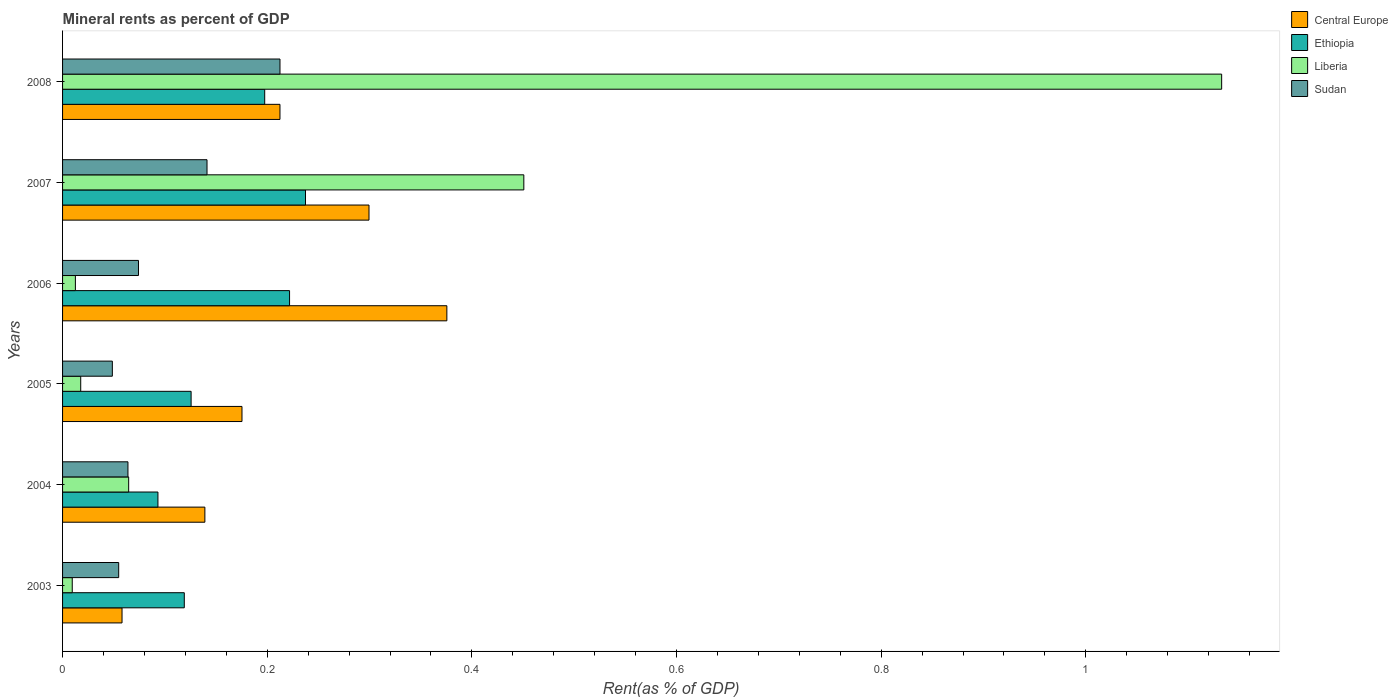How many different coloured bars are there?
Offer a very short reply. 4. How many groups of bars are there?
Provide a succinct answer. 6. Are the number of bars on each tick of the Y-axis equal?
Provide a short and direct response. Yes. How many bars are there on the 1st tick from the top?
Provide a short and direct response. 4. In how many cases, is the number of bars for a given year not equal to the number of legend labels?
Provide a succinct answer. 0. What is the mineral rent in Ethiopia in 2004?
Offer a terse response. 0.09. Across all years, what is the maximum mineral rent in Liberia?
Offer a very short reply. 1.13. Across all years, what is the minimum mineral rent in Central Europe?
Your answer should be very brief. 0.06. In which year was the mineral rent in Central Europe maximum?
Offer a terse response. 2006. In which year was the mineral rent in Central Europe minimum?
Ensure brevity in your answer.  2003. What is the total mineral rent in Sudan in the graph?
Make the answer very short. 0.6. What is the difference between the mineral rent in Sudan in 2003 and that in 2007?
Give a very brief answer. -0.09. What is the difference between the mineral rent in Liberia in 2008 and the mineral rent in Central Europe in 2003?
Offer a terse response. 1.07. What is the average mineral rent in Liberia per year?
Provide a short and direct response. 0.28. In the year 2006, what is the difference between the mineral rent in Sudan and mineral rent in Ethiopia?
Your response must be concise. -0.15. What is the ratio of the mineral rent in Liberia in 2007 to that in 2008?
Offer a terse response. 0.4. Is the difference between the mineral rent in Sudan in 2004 and 2006 greater than the difference between the mineral rent in Ethiopia in 2004 and 2006?
Your answer should be compact. Yes. What is the difference between the highest and the second highest mineral rent in Central Europe?
Your response must be concise. 0.08. What is the difference between the highest and the lowest mineral rent in Central Europe?
Your answer should be compact. 0.32. In how many years, is the mineral rent in Liberia greater than the average mineral rent in Liberia taken over all years?
Give a very brief answer. 2. What does the 4th bar from the top in 2005 represents?
Your answer should be very brief. Central Europe. What does the 4th bar from the bottom in 2005 represents?
Offer a very short reply. Sudan. Is it the case that in every year, the sum of the mineral rent in Sudan and mineral rent in Liberia is greater than the mineral rent in Central Europe?
Provide a short and direct response. No. How many bars are there?
Make the answer very short. 24. Are all the bars in the graph horizontal?
Provide a short and direct response. Yes. How many years are there in the graph?
Ensure brevity in your answer.  6. What is the difference between two consecutive major ticks on the X-axis?
Provide a succinct answer. 0.2. Are the values on the major ticks of X-axis written in scientific E-notation?
Your answer should be compact. No. Where does the legend appear in the graph?
Give a very brief answer. Top right. How many legend labels are there?
Your answer should be compact. 4. How are the legend labels stacked?
Provide a succinct answer. Vertical. What is the title of the graph?
Offer a very short reply. Mineral rents as percent of GDP. What is the label or title of the X-axis?
Provide a short and direct response. Rent(as % of GDP). What is the label or title of the Y-axis?
Provide a succinct answer. Years. What is the Rent(as % of GDP) in Central Europe in 2003?
Offer a very short reply. 0.06. What is the Rent(as % of GDP) of Ethiopia in 2003?
Keep it short and to the point. 0.12. What is the Rent(as % of GDP) in Liberia in 2003?
Make the answer very short. 0.01. What is the Rent(as % of GDP) in Sudan in 2003?
Make the answer very short. 0.05. What is the Rent(as % of GDP) of Central Europe in 2004?
Your response must be concise. 0.14. What is the Rent(as % of GDP) of Ethiopia in 2004?
Your response must be concise. 0.09. What is the Rent(as % of GDP) in Liberia in 2004?
Provide a short and direct response. 0.06. What is the Rent(as % of GDP) of Sudan in 2004?
Offer a very short reply. 0.06. What is the Rent(as % of GDP) in Central Europe in 2005?
Your answer should be very brief. 0.18. What is the Rent(as % of GDP) of Ethiopia in 2005?
Make the answer very short. 0.13. What is the Rent(as % of GDP) in Liberia in 2005?
Provide a short and direct response. 0.02. What is the Rent(as % of GDP) in Sudan in 2005?
Ensure brevity in your answer.  0.05. What is the Rent(as % of GDP) in Central Europe in 2006?
Your answer should be very brief. 0.38. What is the Rent(as % of GDP) of Ethiopia in 2006?
Ensure brevity in your answer.  0.22. What is the Rent(as % of GDP) of Liberia in 2006?
Offer a terse response. 0.01. What is the Rent(as % of GDP) of Sudan in 2006?
Give a very brief answer. 0.07. What is the Rent(as % of GDP) of Central Europe in 2007?
Give a very brief answer. 0.3. What is the Rent(as % of GDP) in Ethiopia in 2007?
Ensure brevity in your answer.  0.24. What is the Rent(as % of GDP) of Liberia in 2007?
Provide a succinct answer. 0.45. What is the Rent(as % of GDP) of Sudan in 2007?
Provide a short and direct response. 0.14. What is the Rent(as % of GDP) in Central Europe in 2008?
Your answer should be compact. 0.21. What is the Rent(as % of GDP) in Ethiopia in 2008?
Your answer should be very brief. 0.2. What is the Rent(as % of GDP) in Liberia in 2008?
Keep it short and to the point. 1.13. What is the Rent(as % of GDP) in Sudan in 2008?
Keep it short and to the point. 0.21. Across all years, what is the maximum Rent(as % of GDP) in Central Europe?
Your answer should be compact. 0.38. Across all years, what is the maximum Rent(as % of GDP) in Ethiopia?
Ensure brevity in your answer.  0.24. Across all years, what is the maximum Rent(as % of GDP) in Liberia?
Keep it short and to the point. 1.13. Across all years, what is the maximum Rent(as % of GDP) of Sudan?
Offer a very short reply. 0.21. Across all years, what is the minimum Rent(as % of GDP) in Central Europe?
Your response must be concise. 0.06. Across all years, what is the minimum Rent(as % of GDP) of Ethiopia?
Offer a very short reply. 0.09. Across all years, what is the minimum Rent(as % of GDP) in Liberia?
Your response must be concise. 0.01. Across all years, what is the minimum Rent(as % of GDP) of Sudan?
Provide a short and direct response. 0.05. What is the total Rent(as % of GDP) in Central Europe in the graph?
Provide a short and direct response. 1.26. What is the total Rent(as % of GDP) in Ethiopia in the graph?
Keep it short and to the point. 0.99. What is the total Rent(as % of GDP) of Liberia in the graph?
Keep it short and to the point. 1.69. What is the total Rent(as % of GDP) of Sudan in the graph?
Your answer should be compact. 0.6. What is the difference between the Rent(as % of GDP) in Central Europe in 2003 and that in 2004?
Provide a short and direct response. -0.08. What is the difference between the Rent(as % of GDP) in Ethiopia in 2003 and that in 2004?
Offer a very short reply. 0.03. What is the difference between the Rent(as % of GDP) in Liberia in 2003 and that in 2004?
Provide a short and direct response. -0.06. What is the difference between the Rent(as % of GDP) of Sudan in 2003 and that in 2004?
Provide a short and direct response. -0.01. What is the difference between the Rent(as % of GDP) of Central Europe in 2003 and that in 2005?
Make the answer very short. -0.12. What is the difference between the Rent(as % of GDP) in Ethiopia in 2003 and that in 2005?
Give a very brief answer. -0.01. What is the difference between the Rent(as % of GDP) in Liberia in 2003 and that in 2005?
Provide a short and direct response. -0.01. What is the difference between the Rent(as % of GDP) of Sudan in 2003 and that in 2005?
Give a very brief answer. 0.01. What is the difference between the Rent(as % of GDP) in Central Europe in 2003 and that in 2006?
Provide a short and direct response. -0.32. What is the difference between the Rent(as % of GDP) of Ethiopia in 2003 and that in 2006?
Give a very brief answer. -0.1. What is the difference between the Rent(as % of GDP) in Liberia in 2003 and that in 2006?
Ensure brevity in your answer.  -0. What is the difference between the Rent(as % of GDP) of Sudan in 2003 and that in 2006?
Provide a short and direct response. -0.02. What is the difference between the Rent(as % of GDP) of Central Europe in 2003 and that in 2007?
Your answer should be compact. -0.24. What is the difference between the Rent(as % of GDP) of Ethiopia in 2003 and that in 2007?
Keep it short and to the point. -0.12. What is the difference between the Rent(as % of GDP) in Liberia in 2003 and that in 2007?
Your response must be concise. -0.44. What is the difference between the Rent(as % of GDP) of Sudan in 2003 and that in 2007?
Offer a very short reply. -0.09. What is the difference between the Rent(as % of GDP) in Central Europe in 2003 and that in 2008?
Make the answer very short. -0.15. What is the difference between the Rent(as % of GDP) in Ethiopia in 2003 and that in 2008?
Provide a short and direct response. -0.08. What is the difference between the Rent(as % of GDP) in Liberia in 2003 and that in 2008?
Provide a short and direct response. -1.12. What is the difference between the Rent(as % of GDP) of Sudan in 2003 and that in 2008?
Keep it short and to the point. -0.16. What is the difference between the Rent(as % of GDP) of Central Europe in 2004 and that in 2005?
Ensure brevity in your answer.  -0.04. What is the difference between the Rent(as % of GDP) in Ethiopia in 2004 and that in 2005?
Offer a very short reply. -0.03. What is the difference between the Rent(as % of GDP) of Liberia in 2004 and that in 2005?
Provide a succinct answer. 0.05. What is the difference between the Rent(as % of GDP) in Sudan in 2004 and that in 2005?
Offer a terse response. 0.02. What is the difference between the Rent(as % of GDP) in Central Europe in 2004 and that in 2006?
Your response must be concise. -0.24. What is the difference between the Rent(as % of GDP) in Ethiopia in 2004 and that in 2006?
Provide a succinct answer. -0.13. What is the difference between the Rent(as % of GDP) of Liberia in 2004 and that in 2006?
Provide a short and direct response. 0.05. What is the difference between the Rent(as % of GDP) of Sudan in 2004 and that in 2006?
Your answer should be very brief. -0.01. What is the difference between the Rent(as % of GDP) in Central Europe in 2004 and that in 2007?
Provide a short and direct response. -0.16. What is the difference between the Rent(as % of GDP) in Ethiopia in 2004 and that in 2007?
Your response must be concise. -0.14. What is the difference between the Rent(as % of GDP) in Liberia in 2004 and that in 2007?
Offer a very short reply. -0.39. What is the difference between the Rent(as % of GDP) of Sudan in 2004 and that in 2007?
Offer a terse response. -0.08. What is the difference between the Rent(as % of GDP) in Central Europe in 2004 and that in 2008?
Your answer should be compact. -0.07. What is the difference between the Rent(as % of GDP) of Ethiopia in 2004 and that in 2008?
Provide a succinct answer. -0.1. What is the difference between the Rent(as % of GDP) in Liberia in 2004 and that in 2008?
Provide a succinct answer. -1.07. What is the difference between the Rent(as % of GDP) of Sudan in 2004 and that in 2008?
Keep it short and to the point. -0.15. What is the difference between the Rent(as % of GDP) in Central Europe in 2005 and that in 2006?
Keep it short and to the point. -0.2. What is the difference between the Rent(as % of GDP) of Ethiopia in 2005 and that in 2006?
Keep it short and to the point. -0.1. What is the difference between the Rent(as % of GDP) of Liberia in 2005 and that in 2006?
Offer a very short reply. 0.01. What is the difference between the Rent(as % of GDP) of Sudan in 2005 and that in 2006?
Your answer should be compact. -0.03. What is the difference between the Rent(as % of GDP) in Central Europe in 2005 and that in 2007?
Your answer should be compact. -0.12. What is the difference between the Rent(as % of GDP) of Ethiopia in 2005 and that in 2007?
Keep it short and to the point. -0.11. What is the difference between the Rent(as % of GDP) of Liberia in 2005 and that in 2007?
Offer a very short reply. -0.43. What is the difference between the Rent(as % of GDP) in Sudan in 2005 and that in 2007?
Keep it short and to the point. -0.09. What is the difference between the Rent(as % of GDP) of Central Europe in 2005 and that in 2008?
Your response must be concise. -0.04. What is the difference between the Rent(as % of GDP) in Ethiopia in 2005 and that in 2008?
Provide a short and direct response. -0.07. What is the difference between the Rent(as % of GDP) of Liberia in 2005 and that in 2008?
Provide a succinct answer. -1.11. What is the difference between the Rent(as % of GDP) in Sudan in 2005 and that in 2008?
Provide a short and direct response. -0.16. What is the difference between the Rent(as % of GDP) of Central Europe in 2006 and that in 2007?
Keep it short and to the point. 0.08. What is the difference between the Rent(as % of GDP) of Ethiopia in 2006 and that in 2007?
Keep it short and to the point. -0.02. What is the difference between the Rent(as % of GDP) in Liberia in 2006 and that in 2007?
Offer a terse response. -0.44. What is the difference between the Rent(as % of GDP) in Sudan in 2006 and that in 2007?
Your answer should be compact. -0.07. What is the difference between the Rent(as % of GDP) of Central Europe in 2006 and that in 2008?
Keep it short and to the point. 0.16. What is the difference between the Rent(as % of GDP) in Ethiopia in 2006 and that in 2008?
Give a very brief answer. 0.02. What is the difference between the Rent(as % of GDP) in Liberia in 2006 and that in 2008?
Offer a very short reply. -1.12. What is the difference between the Rent(as % of GDP) in Sudan in 2006 and that in 2008?
Provide a short and direct response. -0.14. What is the difference between the Rent(as % of GDP) of Central Europe in 2007 and that in 2008?
Give a very brief answer. 0.09. What is the difference between the Rent(as % of GDP) of Ethiopia in 2007 and that in 2008?
Keep it short and to the point. 0.04. What is the difference between the Rent(as % of GDP) of Liberia in 2007 and that in 2008?
Your answer should be compact. -0.68. What is the difference between the Rent(as % of GDP) of Sudan in 2007 and that in 2008?
Offer a terse response. -0.07. What is the difference between the Rent(as % of GDP) in Central Europe in 2003 and the Rent(as % of GDP) in Ethiopia in 2004?
Provide a succinct answer. -0.04. What is the difference between the Rent(as % of GDP) of Central Europe in 2003 and the Rent(as % of GDP) of Liberia in 2004?
Keep it short and to the point. -0.01. What is the difference between the Rent(as % of GDP) in Central Europe in 2003 and the Rent(as % of GDP) in Sudan in 2004?
Provide a short and direct response. -0.01. What is the difference between the Rent(as % of GDP) in Ethiopia in 2003 and the Rent(as % of GDP) in Liberia in 2004?
Your answer should be very brief. 0.05. What is the difference between the Rent(as % of GDP) in Ethiopia in 2003 and the Rent(as % of GDP) in Sudan in 2004?
Ensure brevity in your answer.  0.06. What is the difference between the Rent(as % of GDP) of Liberia in 2003 and the Rent(as % of GDP) of Sudan in 2004?
Make the answer very short. -0.05. What is the difference between the Rent(as % of GDP) in Central Europe in 2003 and the Rent(as % of GDP) in Ethiopia in 2005?
Offer a very short reply. -0.07. What is the difference between the Rent(as % of GDP) in Central Europe in 2003 and the Rent(as % of GDP) in Liberia in 2005?
Provide a short and direct response. 0.04. What is the difference between the Rent(as % of GDP) of Central Europe in 2003 and the Rent(as % of GDP) of Sudan in 2005?
Your answer should be very brief. 0.01. What is the difference between the Rent(as % of GDP) in Ethiopia in 2003 and the Rent(as % of GDP) in Liberia in 2005?
Your answer should be compact. 0.1. What is the difference between the Rent(as % of GDP) of Ethiopia in 2003 and the Rent(as % of GDP) of Sudan in 2005?
Keep it short and to the point. 0.07. What is the difference between the Rent(as % of GDP) in Liberia in 2003 and the Rent(as % of GDP) in Sudan in 2005?
Provide a succinct answer. -0.04. What is the difference between the Rent(as % of GDP) of Central Europe in 2003 and the Rent(as % of GDP) of Ethiopia in 2006?
Offer a very short reply. -0.16. What is the difference between the Rent(as % of GDP) in Central Europe in 2003 and the Rent(as % of GDP) in Liberia in 2006?
Ensure brevity in your answer.  0.05. What is the difference between the Rent(as % of GDP) in Central Europe in 2003 and the Rent(as % of GDP) in Sudan in 2006?
Your response must be concise. -0.02. What is the difference between the Rent(as % of GDP) of Ethiopia in 2003 and the Rent(as % of GDP) of Liberia in 2006?
Keep it short and to the point. 0.11. What is the difference between the Rent(as % of GDP) of Ethiopia in 2003 and the Rent(as % of GDP) of Sudan in 2006?
Offer a terse response. 0.04. What is the difference between the Rent(as % of GDP) of Liberia in 2003 and the Rent(as % of GDP) of Sudan in 2006?
Give a very brief answer. -0.06. What is the difference between the Rent(as % of GDP) of Central Europe in 2003 and the Rent(as % of GDP) of Ethiopia in 2007?
Offer a very short reply. -0.18. What is the difference between the Rent(as % of GDP) in Central Europe in 2003 and the Rent(as % of GDP) in Liberia in 2007?
Your response must be concise. -0.39. What is the difference between the Rent(as % of GDP) in Central Europe in 2003 and the Rent(as % of GDP) in Sudan in 2007?
Your response must be concise. -0.08. What is the difference between the Rent(as % of GDP) in Ethiopia in 2003 and the Rent(as % of GDP) in Liberia in 2007?
Provide a succinct answer. -0.33. What is the difference between the Rent(as % of GDP) of Ethiopia in 2003 and the Rent(as % of GDP) of Sudan in 2007?
Keep it short and to the point. -0.02. What is the difference between the Rent(as % of GDP) of Liberia in 2003 and the Rent(as % of GDP) of Sudan in 2007?
Keep it short and to the point. -0.13. What is the difference between the Rent(as % of GDP) in Central Europe in 2003 and the Rent(as % of GDP) in Ethiopia in 2008?
Provide a short and direct response. -0.14. What is the difference between the Rent(as % of GDP) in Central Europe in 2003 and the Rent(as % of GDP) in Liberia in 2008?
Give a very brief answer. -1.07. What is the difference between the Rent(as % of GDP) of Central Europe in 2003 and the Rent(as % of GDP) of Sudan in 2008?
Give a very brief answer. -0.15. What is the difference between the Rent(as % of GDP) in Ethiopia in 2003 and the Rent(as % of GDP) in Liberia in 2008?
Your answer should be compact. -1.01. What is the difference between the Rent(as % of GDP) in Ethiopia in 2003 and the Rent(as % of GDP) in Sudan in 2008?
Keep it short and to the point. -0.09. What is the difference between the Rent(as % of GDP) of Liberia in 2003 and the Rent(as % of GDP) of Sudan in 2008?
Your answer should be compact. -0.2. What is the difference between the Rent(as % of GDP) in Central Europe in 2004 and the Rent(as % of GDP) in Ethiopia in 2005?
Keep it short and to the point. 0.01. What is the difference between the Rent(as % of GDP) of Central Europe in 2004 and the Rent(as % of GDP) of Liberia in 2005?
Offer a terse response. 0.12. What is the difference between the Rent(as % of GDP) of Central Europe in 2004 and the Rent(as % of GDP) of Sudan in 2005?
Your response must be concise. 0.09. What is the difference between the Rent(as % of GDP) in Ethiopia in 2004 and the Rent(as % of GDP) in Liberia in 2005?
Make the answer very short. 0.08. What is the difference between the Rent(as % of GDP) in Ethiopia in 2004 and the Rent(as % of GDP) in Sudan in 2005?
Make the answer very short. 0.04. What is the difference between the Rent(as % of GDP) in Liberia in 2004 and the Rent(as % of GDP) in Sudan in 2005?
Your answer should be compact. 0.02. What is the difference between the Rent(as % of GDP) in Central Europe in 2004 and the Rent(as % of GDP) in Ethiopia in 2006?
Provide a succinct answer. -0.08. What is the difference between the Rent(as % of GDP) of Central Europe in 2004 and the Rent(as % of GDP) of Liberia in 2006?
Provide a short and direct response. 0.13. What is the difference between the Rent(as % of GDP) of Central Europe in 2004 and the Rent(as % of GDP) of Sudan in 2006?
Make the answer very short. 0.06. What is the difference between the Rent(as % of GDP) of Ethiopia in 2004 and the Rent(as % of GDP) of Liberia in 2006?
Provide a short and direct response. 0.08. What is the difference between the Rent(as % of GDP) in Ethiopia in 2004 and the Rent(as % of GDP) in Sudan in 2006?
Your answer should be very brief. 0.02. What is the difference between the Rent(as % of GDP) of Liberia in 2004 and the Rent(as % of GDP) of Sudan in 2006?
Provide a succinct answer. -0.01. What is the difference between the Rent(as % of GDP) in Central Europe in 2004 and the Rent(as % of GDP) in Ethiopia in 2007?
Ensure brevity in your answer.  -0.1. What is the difference between the Rent(as % of GDP) of Central Europe in 2004 and the Rent(as % of GDP) of Liberia in 2007?
Ensure brevity in your answer.  -0.31. What is the difference between the Rent(as % of GDP) in Central Europe in 2004 and the Rent(as % of GDP) in Sudan in 2007?
Your answer should be very brief. -0. What is the difference between the Rent(as % of GDP) of Ethiopia in 2004 and the Rent(as % of GDP) of Liberia in 2007?
Your answer should be compact. -0.36. What is the difference between the Rent(as % of GDP) in Ethiopia in 2004 and the Rent(as % of GDP) in Sudan in 2007?
Ensure brevity in your answer.  -0.05. What is the difference between the Rent(as % of GDP) of Liberia in 2004 and the Rent(as % of GDP) of Sudan in 2007?
Make the answer very short. -0.08. What is the difference between the Rent(as % of GDP) of Central Europe in 2004 and the Rent(as % of GDP) of Ethiopia in 2008?
Provide a short and direct response. -0.06. What is the difference between the Rent(as % of GDP) in Central Europe in 2004 and the Rent(as % of GDP) in Liberia in 2008?
Your answer should be very brief. -0.99. What is the difference between the Rent(as % of GDP) in Central Europe in 2004 and the Rent(as % of GDP) in Sudan in 2008?
Ensure brevity in your answer.  -0.07. What is the difference between the Rent(as % of GDP) in Ethiopia in 2004 and the Rent(as % of GDP) in Liberia in 2008?
Your answer should be very brief. -1.04. What is the difference between the Rent(as % of GDP) in Ethiopia in 2004 and the Rent(as % of GDP) in Sudan in 2008?
Provide a short and direct response. -0.12. What is the difference between the Rent(as % of GDP) of Liberia in 2004 and the Rent(as % of GDP) of Sudan in 2008?
Your answer should be compact. -0.15. What is the difference between the Rent(as % of GDP) in Central Europe in 2005 and the Rent(as % of GDP) in Ethiopia in 2006?
Offer a terse response. -0.05. What is the difference between the Rent(as % of GDP) of Central Europe in 2005 and the Rent(as % of GDP) of Liberia in 2006?
Your answer should be very brief. 0.16. What is the difference between the Rent(as % of GDP) of Central Europe in 2005 and the Rent(as % of GDP) of Sudan in 2006?
Ensure brevity in your answer.  0.1. What is the difference between the Rent(as % of GDP) in Ethiopia in 2005 and the Rent(as % of GDP) in Liberia in 2006?
Ensure brevity in your answer.  0.11. What is the difference between the Rent(as % of GDP) in Ethiopia in 2005 and the Rent(as % of GDP) in Sudan in 2006?
Offer a very short reply. 0.05. What is the difference between the Rent(as % of GDP) in Liberia in 2005 and the Rent(as % of GDP) in Sudan in 2006?
Make the answer very short. -0.06. What is the difference between the Rent(as % of GDP) in Central Europe in 2005 and the Rent(as % of GDP) in Ethiopia in 2007?
Offer a very short reply. -0.06. What is the difference between the Rent(as % of GDP) in Central Europe in 2005 and the Rent(as % of GDP) in Liberia in 2007?
Keep it short and to the point. -0.28. What is the difference between the Rent(as % of GDP) of Central Europe in 2005 and the Rent(as % of GDP) of Sudan in 2007?
Offer a terse response. 0.03. What is the difference between the Rent(as % of GDP) in Ethiopia in 2005 and the Rent(as % of GDP) in Liberia in 2007?
Provide a short and direct response. -0.33. What is the difference between the Rent(as % of GDP) in Ethiopia in 2005 and the Rent(as % of GDP) in Sudan in 2007?
Your answer should be compact. -0.02. What is the difference between the Rent(as % of GDP) of Liberia in 2005 and the Rent(as % of GDP) of Sudan in 2007?
Your response must be concise. -0.12. What is the difference between the Rent(as % of GDP) of Central Europe in 2005 and the Rent(as % of GDP) of Ethiopia in 2008?
Make the answer very short. -0.02. What is the difference between the Rent(as % of GDP) in Central Europe in 2005 and the Rent(as % of GDP) in Liberia in 2008?
Your answer should be very brief. -0.96. What is the difference between the Rent(as % of GDP) of Central Europe in 2005 and the Rent(as % of GDP) of Sudan in 2008?
Make the answer very short. -0.04. What is the difference between the Rent(as % of GDP) of Ethiopia in 2005 and the Rent(as % of GDP) of Liberia in 2008?
Offer a very short reply. -1.01. What is the difference between the Rent(as % of GDP) in Ethiopia in 2005 and the Rent(as % of GDP) in Sudan in 2008?
Provide a succinct answer. -0.09. What is the difference between the Rent(as % of GDP) in Liberia in 2005 and the Rent(as % of GDP) in Sudan in 2008?
Offer a very short reply. -0.19. What is the difference between the Rent(as % of GDP) in Central Europe in 2006 and the Rent(as % of GDP) in Ethiopia in 2007?
Keep it short and to the point. 0.14. What is the difference between the Rent(as % of GDP) of Central Europe in 2006 and the Rent(as % of GDP) of Liberia in 2007?
Offer a terse response. -0.08. What is the difference between the Rent(as % of GDP) in Central Europe in 2006 and the Rent(as % of GDP) in Sudan in 2007?
Ensure brevity in your answer.  0.23. What is the difference between the Rent(as % of GDP) of Ethiopia in 2006 and the Rent(as % of GDP) of Liberia in 2007?
Ensure brevity in your answer.  -0.23. What is the difference between the Rent(as % of GDP) in Ethiopia in 2006 and the Rent(as % of GDP) in Sudan in 2007?
Provide a short and direct response. 0.08. What is the difference between the Rent(as % of GDP) of Liberia in 2006 and the Rent(as % of GDP) of Sudan in 2007?
Keep it short and to the point. -0.13. What is the difference between the Rent(as % of GDP) of Central Europe in 2006 and the Rent(as % of GDP) of Ethiopia in 2008?
Your answer should be very brief. 0.18. What is the difference between the Rent(as % of GDP) of Central Europe in 2006 and the Rent(as % of GDP) of Liberia in 2008?
Give a very brief answer. -0.76. What is the difference between the Rent(as % of GDP) in Central Europe in 2006 and the Rent(as % of GDP) in Sudan in 2008?
Offer a very short reply. 0.16. What is the difference between the Rent(as % of GDP) of Ethiopia in 2006 and the Rent(as % of GDP) of Liberia in 2008?
Provide a succinct answer. -0.91. What is the difference between the Rent(as % of GDP) of Ethiopia in 2006 and the Rent(as % of GDP) of Sudan in 2008?
Your answer should be very brief. 0.01. What is the difference between the Rent(as % of GDP) in Liberia in 2006 and the Rent(as % of GDP) in Sudan in 2008?
Give a very brief answer. -0.2. What is the difference between the Rent(as % of GDP) in Central Europe in 2007 and the Rent(as % of GDP) in Ethiopia in 2008?
Your answer should be compact. 0.1. What is the difference between the Rent(as % of GDP) of Central Europe in 2007 and the Rent(as % of GDP) of Sudan in 2008?
Offer a very short reply. 0.09. What is the difference between the Rent(as % of GDP) in Ethiopia in 2007 and the Rent(as % of GDP) in Liberia in 2008?
Provide a succinct answer. -0.9. What is the difference between the Rent(as % of GDP) of Ethiopia in 2007 and the Rent(as % of GDP) of Sudan in 2008?
Offer a very short reply. 0.02. What is the difference between the Rent(as % of GDP) in Liberia in 2007 and the Rent(as % of GDP) in Sudan in 2008?
Offer a terse response. 0.24. What is the average Rent(as % of GDP) in Central Europe per year?
Your response must be concise. 0.21. What is the average Rent(as % of GDP) of Ethiopia per year?
Provide a succinct answer. 0.17. What is the average Rent(as % of GDP) of Liberia per year?
Provide a short and direct response. 0.28. What is the average Rent(as % of GDP) of Sudan per year?
Offer a terse response. 0.1. In the year 2003, what is the difference between the Rent(as % of GDP) in Central Europe and Rent(as % of GDP) in Ethiopia?
Your answer should be compact. -0.06. In the year 2003, what is the difference between the Rent(as % of GDP) of Central Europe and Rent(as % of GDP) of Liberia?
Offer a terse response. 0.05. In the year 2003, what is the difference between the Rent(as % of GDP) of Central Europe and Rent(as % of GDP) of Sudan?
Make the answer very short. 0. In the year 2003, what is the difference between the Rent(as % of GDP) of Ethiopia and Rent(as % of GDP) of Liberia?
Make the answer very short. 0.11. In the year 2003, what is the difference between the Rent(as % of GDP) of Ethiopia and Rent(as % of GDP) of Sudan?
Your response must be concise. 0.06. In the year 2003, what is the difference between the Rent(as % of GDP) of Liberia and Rent(as % of GDP) of Sudan?
Keep it short and to the point. -0.05. In the year 2004, what is the difference between the Rent(as % of GDP) in Central Europe and Rent(as % of GDP) in Ethiopia?
Ensure brevity in your answer.  0.05. In the year 2004, what is the difference between the Rent(as % of GDP) of Central Europe and Rent(as % of GDP) of Liberia?
Your response must be concise. 0.07. In the year 2004, what is the difference between the Rent(as % of GDP) in Central Europe and Rent(as % of GDP) in Sudan?
Ensure brevity in your answer.  0.08. In the year 2004, what is the difference between the Rent(as % of GDP) of Ethiopia and Rent(as % of GDP) of Liberia?
Your answer should be compact. 0.03. In the year 2004, what is the difference between the Rent(as % of GDP) in Ethiopia and Rent(as % of GDP) in Sudan?
Offer a very short reply. 0.03. In the year 2004, what is the difference between the Rent(as % of GDP) of Liberia and Rent(as % of GDP) of Sudan?
Give a very brief answer. 0. In the year 2005, what is the difference between the Rent(as % of GDP) in Central Europe and Rent(as % of GDP) in Ethiopia?
Ensure brevity in your answer.  0.05. In the year 2005, what is the difference between the Rent(as % of GDP) in Central Europe and Rent(as % of GDP) in Liberia?
Offer a terse response. 0.16. In the year 2005, what is the difference between the Rent(as % of GDP) of Central Europe and Rent(as % of GDP) of Sudan?
Your response must be concise. 0.13. In the year 2005, what is the difference between the Rent(as % of GDP) of Ethiopia and Rent(as % of GDP) of Liberia?
Provide a short and direct response. 0.11. In the year 2005, what is the difference between the Rent(as % of GDP) in Ethiopia and Rent(as % of GDP) in Sudan?
Ensure brevity in your answer.  0.08. In the year 2005, what is the difference between the Rent(as % of GDP) in Liberia and Rent(as % of GDP) in Sudan?
Ensure brevity in your answer.  -0.03. In the year 2006, what is the difference between the Rent(as % of GDP) in Central Europe and Rent(as % of GDP) in Ethiopia?
Your answer should be very brief. 0.15. In the year 2006, what is the difference between the Rent(as % of GDP) of Central Europe and Rent(as % of GDP) of Liberia?
Provide a succinct answer. 0.36. In the year 2006, what is the difference between the Rent(as % of GDP) in Central Europe and Rent(as % of GDP) in Sudan?
Offer a terse response. 0.3. In the year 2006, what is the difference between the Rent(as % of GDP) in Ethiopia and Rent(as % of GDP) in Liberia?
Make the answer very short. 0.21. In the year 2006, what is the difference between the Rent(as % of GDP) of Ethiopia and Rent(as % of GDP) of Sudan?
Your answer should be compact. 0.15. In the year 2006, what is the difference between the Rent(as % of GDP) of Liberia and Rent(as % of GDP) of Sudan?
Offer a very short reply. -0.06. In the year 2007, what is the difference between the Rent(as % of GDP) of Central Europe and Rent(as % of GDP) of Ethiopia?
Your answer should be compact. 0.06. In the year 2007, what is the difference between the Rent(as % of GDP) of Central Europe and Rent(as % of GDP) of Liberia?
Offer a very short reply. -0.15. In the year 2007, what is the difference between the Rent(as % of GDP) in Central Europe and Rent(as % of GDP) in Sudan?
Provide a succinct answer. 0.16. In the year 2007, what is the difference between the Rent(as % of GDP) in Ethiopia and Rent(as % of GDP) in Liberia?
Keep it short and to the point. -0.21. In the year 2007, what is the difference between the Rent(as % of GDP) of Ethiopia and Rent(as % of GDP) of Sudan?
Ensure brevity in your answer.  0.1. In the year 2007, what is the difference between the Rent(as % of GDP) in Liberia and Rent(as % of GDP) in Sudan?
Ensure brevity in your answer.  0.31. In the year 2008, what is the difference between the Rent(as % of GDP) in Central Europe and Rent(as % of GDP) in Ethiopia?
Keep it short and to the point. 0.01. In the year 2008, what is the difference between the Rent(as % of GDP) of Central Europe and Rent(as % of GDP) of Liberia?
Provide a succinct answer. -0.92. In the year 2008, what is the difference between the Rent(as % of GDP) in Ethiopia and Rent(as % of GDP) in Liberia?
Ensure brevity in your answer.  -0.94. In the year 2008, what is the difference between the Rent(as % of GDP) of Ethiopia and Rent(as % of GDP) of Sudan?
Provide a succinct answer. -0.01. In the year 2008, what is the difference between the Rent(as % of GDP) in Liberia and Rent(as % of GDP) in Sudan?
Make the answer very short. 0.92. What is the ratio of the Rent(as % of GDP) in Central Europe in 2003 to that in 2004?
Provide a short and direct response. 0.42. What is the ratio of the Rent(as % of GDP) in Ethiopia in 2003 to that in 2004?
Provide a short and direct response. 1.28. What is the ratio of the Rent(as % of GDP) of Liberia in 2003 to that in 2004?
Make the answer very short. 0.15. What is the ratio of the Rent(as % of GDP) of Sudan in 2003 to that in 2004?
Your answer should be very brief. 0.86. What is the ratio of the Rent(as % of GDP) of Central Europe in 2003 to that in 2005?
Keep it short and to the point. 0.33. What is the ratio of the Rent(as % of GDP) of Ethiopia in 2003 to that in 2005?
Provide a succinct answer. 0.95. What is the ratio of the Rent(as % of GDP) of Liberia in 2003 to that in 2005?
Your answer should be very brief. 0.53. What is the ratio of the Rent(as % of GDP) of Sudan in 2003 to that in 2005?
Your response must be concise. 1.13. What is the ratio of the Rent(as % of GDP) in Central Europe in 2003 to that in 2006?
Your answer should be compact. 0.15. What is the ratio of the Rent(as % of GDP) of Ethiopia in 2003 to that in 2006?
Your response must be concise. 0.54. What is the ratio of the Rent(as % of GDP) in Liberia in 2003 to that in 2006?
Offer a terse response. 0.75. What is the ratio of the Rent(as % of GDP) in Sudan in 2003 to that in 2006?
Ensure brevity in your answer.  0.74. What is the ratio of the Rent(as % of GDP) of Central Europe in 2003 to that in 2007?
Give a very brief answer. 0.19. What is the ratio of the Rent(as % of GDP) in Ethiopia in 2003 to that in 2007?
Your answer should be compact. 0.5. What is the ratio of the Rent(as % of GDP) in Liberia in 2003 to that in 2007?
Keep it short and to the point. 0.02. What is the ratio of the Rent(as % of GDP) of Sudan in 2003 to that in 2007?
Give a very brief answer. 0.39. What is the ratio of the Rent(as % of GDP) in Central Europe in 2003 to that in 2008?
Your answer should be very brief. 0.27. What is the ratio of the Rent(as % of GDP) in Ethiopia in 2003 to that in 2008?
Ensure brevity in your answer.  0.6. What is the ratio of the Rent(as % of GDP) in Liberia in 2003 to that in 2008?
Your answer should be compact. 0.01. What is the ratio of the Rent(as % of GDP) of Sudan in 2003 to that in 2008?
Your answer should be very brief. 0.26. What is the ratio of the Rent(as % of GDP) of Central Europe in 2004 to that in 2005?
Provide a succinct answer. 0.79. What is the ratio of the Rent(as % of GDP) in Ethiopia in 2004 to that in 2005?
Offer a very short reply. 0.74. What is the ratio of the Rent(as % of GDP) in Liberia in 2004 to that in 2005?
Give a very brief answer. 3.64. What is the ratio of the Rent(as % of GDP) of Sudan in 2004 to that in 2005?
Offer a terse response. 1.31. What is the ratio of the Rent(as % of GDP) in Central Europe in 2004 to that in 2006?
Provide a succinct answer. 0.37. What is the ratio of the Rent(as % of GDP) in Ethiopia in 2004 to that in 2006?
Keep it short and to the point. 0.42. What is the ratio of the Rent(as % of GDP) in Liberia in 2004 to that in 2006?
Make the answer very short. 5.15. What is the ratio of the Rent(as % of GDP) in Sudan in 2004 to that in 2006?
Provide a succinct answer. 0.86. What is the ratio of the Rent(as % of GDP) of Central Europe in 2004 to that in 2007?
Your answer should be compact. 0.46. What is the ratio of the Rent(as % of GDP) of Ethiopia in 2004 to that in 2007?
Ensure brevity in your answer.  0.39. What is the ratio of the Rent(as % of GDP) of Liberia in 2004 to that in 2007?
Provide a short and direct response. 0.14. What is the ratio of the Rent(as % of GDP) of Sudan in 2004 to that in 2007?
Give a very brief answer. 0.45. What is the ratio of the Rent(as % of GDP) of Central Europe in 2004 to that in 2008?
Keep it short and to the point. 0.65. What is the ratio of the Rent(as % of GDP) in Ethiopia in 2004 to that in 2008?
Provide a short and direct response. 0.47. What is the ratio of the Rent(as % of GDP) of Liberia in 2004 to that in 2008?
Make the answer very short. 0.06. What is the ratio of the Rent(as % of GDP) in Sudan in 2004 to that in 2008?
Ensure brevity in your answer.  0.3. What is the ratio of the Rent(as % of GDP) in Central Europe in 2005 to that in 2006?
Your response must be concise. 0.47. What is the ratio of the Rent(as % of GDP) of Ethiopia in 2005 to that in 2006?
Provide a short and direct response. 0.57. What is the ratio of the Rent(as % of GDP) in Liberia in 2005 to that in 2006?
Offer a very short reply. 1.41. What is the ratio of the Rent(as % of GDP) of Sudan in 2005 to that in 2006?
Make the answer very short. 0.66. What is the ratio of the Rent(as % of GDP) of Central Europe in 2005 to that in 2007?
Provide a short and direct response. 0.59. What is the ratio of the Rent(as % of GDP) in Ethiopia in 2005 to that in 2007?
Offer a very short reply. 0.53. What is the ratio of the Rent(as % of GDP) in Liberia in 2005 to that in 2007?
Provide a succinct answer. 0.04. What is the ratio of the Rent(as % of GDP) in Sudan in 2005 to that in 2007?
Ensure brevity in your answer.  0.34. What is the ratio of the Rent(as % of GDP) of Central Europe in 2005 to that in 2008?
Keep it short and to the point. 0.83. What is the ratio of the Rent(as % of GDP) of Ethiopia in 2005 to that in 2008?
Keep it short and to the point. 0.64. What is the ratio of the Rent(as % of GDP) of Liberia in 2005 to that in 2008?
Offer a very short reply. 0.02. What is the ratio of the Rent(as % of GDP) in Sudan in 2005 to that in 2008?
Your answer should be very brief. 0.23. What is the ratio of the Rent(as % of GDP) of Central Europe in 2006 to that in 2007?
Keep it short and to the point. 1.25. What is the ratio of the Rent(as % of GDP) of Ethiopia in 2006 to that in 2007?
Offer a terse response. 0.93. What is the ratio of the Rent(as % of GDP) in Liberia in 2006 to that in 2007?
Your answer should be compact. 0.03. What is the ratio of the Rent(as % of GDP) of Sudan in 2006 to that in 2007?
Give a very brief answer. 0.53. What is the ratio of the Rent(as % of GDP) of Central Europe in 2006 to that in 2008?
Provide a succinct answer. 1.77. What is the ratio of the Rent(as % of GDP) in Ethiopia in 2006 to that in 2008?
Ensure brevity in your answer.  1.12. What is the ratio of the Rent(as % of GDP) in Liberia in 2006 to that in 2008?
Keep it short and to the point. 0.01. What is the ratio of the Rent(as % of GDP) of Sudan in 2006 to that in 2008?
Your response must be concise. 0.35. What is the ratio of the Rent(as % of GDP) in Central Europe in 2007 to that in 2008?
Your answer should be very brief. 1.41. What is the ratio of the Rent(as % of GDP) of Ethiopia in 2007 to that in 2008?
Provide a short and direct response. 1.2. What is the ratio of the Rent(as % of GDP) of Liberia in 2007 to that in 2008?
Your answer should be very brief. 0.4. What is the ratio of the Rent(as % of GDP) in Sudan in 2007 to that in 2008?
Ensure brevity in your answer.  0.66. What is the difference between the highest and the second highest Rent(as % of GDP) in Central Europe?
Your answer should be compact. 0.08. What is the difference between the highest and the second highest Rent(as % of GDP) in Ethiopia?
Your answer should be compact. 0.02. What is the difference between the highest and the second highest Rent(as % of GDP) of Liberia?
Your answer should be very brief. 0.68. What is the difference between the highest and the second highest Rent(as % of GDP) in Sudan?
Provide a short and direct response. 0.07. What is the difference between the highest and the lowest Rent(as % of GDP) of Central Europe?
Make the answer very short. 0.32. What is the difference between the highest and the lowest Rent(as % of GDP) of Ethiopia?
Ensure brevity in your answer.  0.14. What is the difference between the highest and the lowest Rent(as % of GDP) in Liberia?
Provide a short and direct response. 1.12. What is the difference between the highest and the lowest Rent(as % of GDP) in Sudan?
Give a very brief answer. 0.16. 